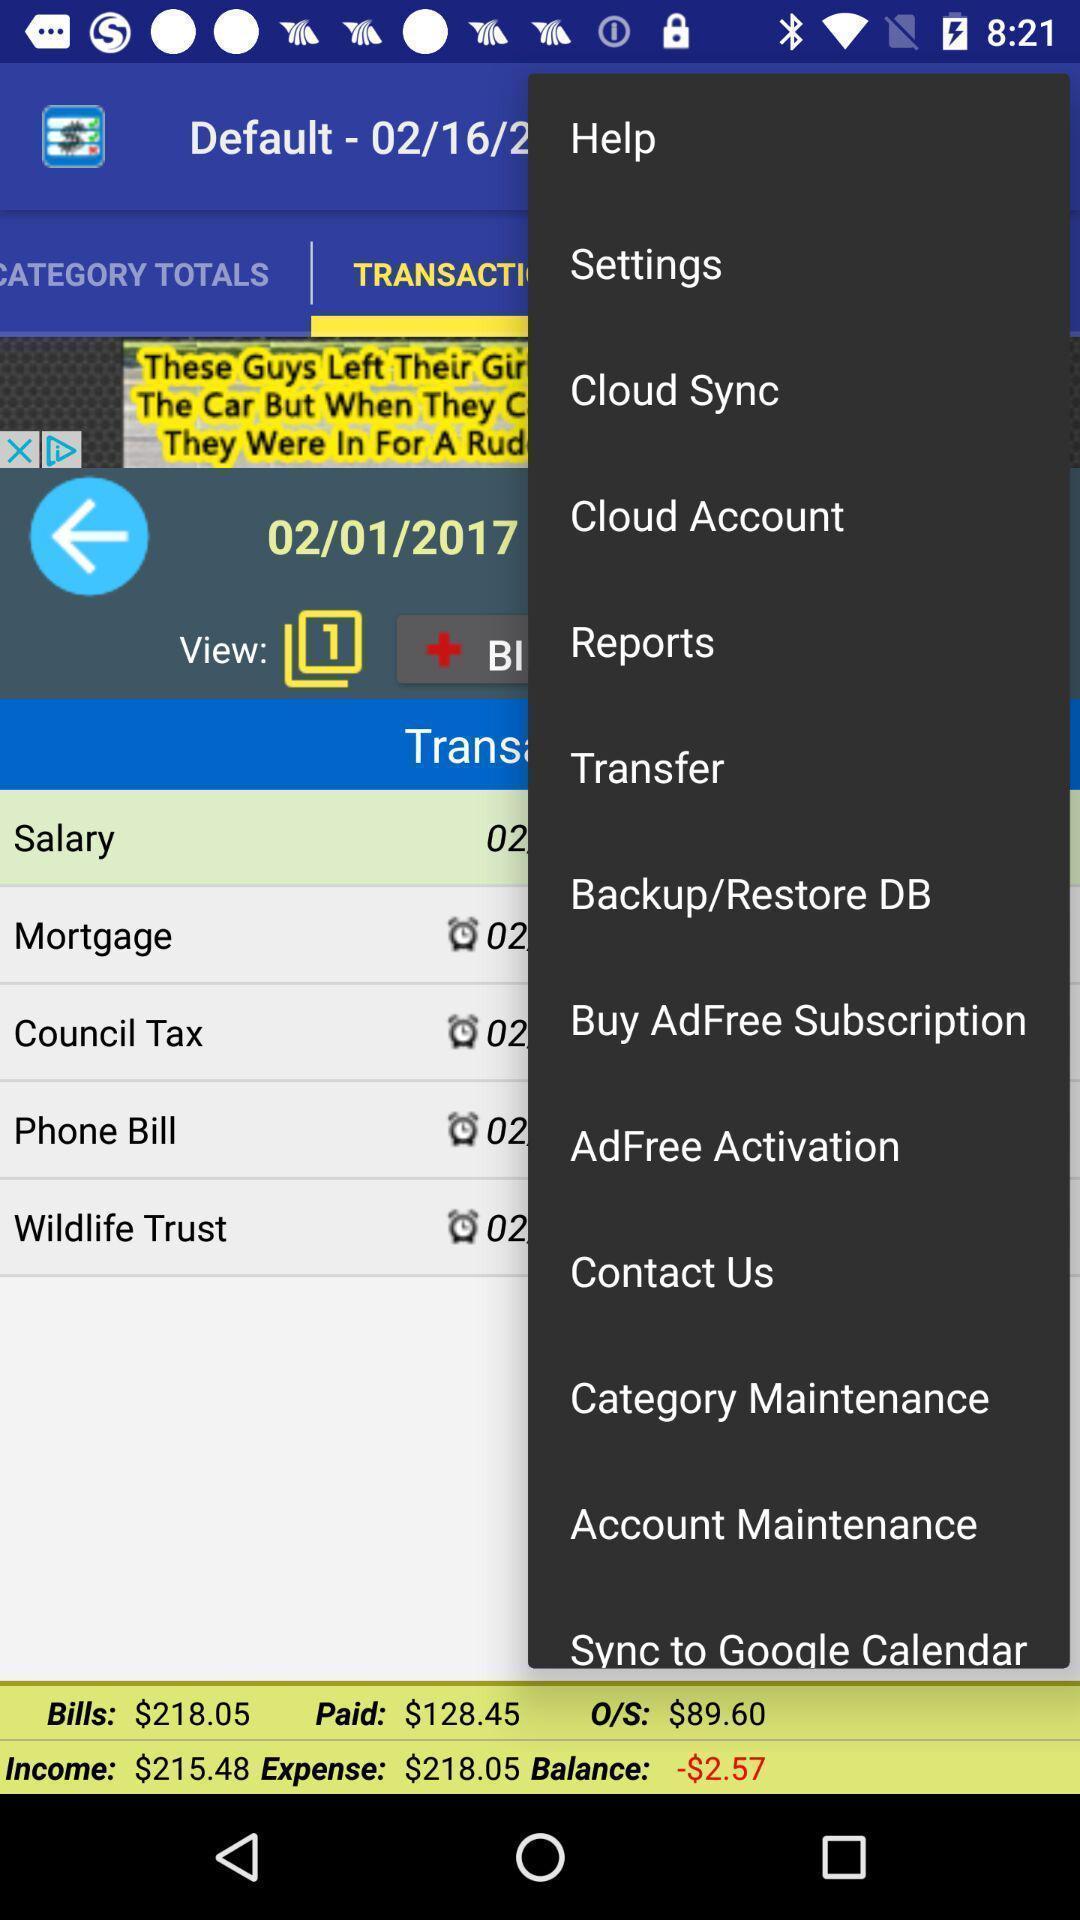Describe the visual elements of this screenshot. Screen displaying multiple options in a financial application. 